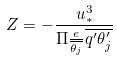Convert formula to latex. <formula><loc_0><loc_0><loc_500><loc_500>Z = - \frac { u _ { * } ^ { 3 } } { \Pi \frac { e } { \overline { \theta _ { j } } } \overline { q ^ { \prime } \theta _ { j } ^ { \prime } } }</formula> 